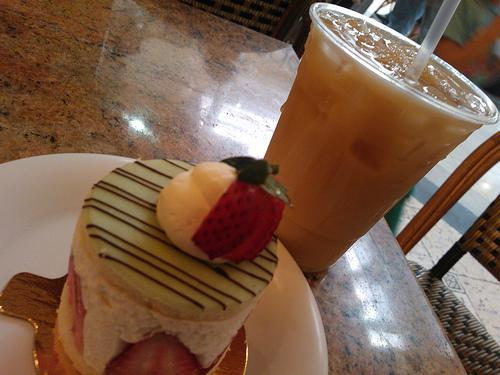Question: what fruit is on top of the dessert?
Choices:
A. Cherries.
B. Strawberry.
C. Raspberries.
D. Blueberries.
Answer with the letter. Answer: B Question: how many desserts are there?
Choices:
A. One.
B. Two.
C. Three.
D. Four.
Answer with the letter. Answer: A Question: what is sticking out of the drink?
Choices:
A. A lemon.
B. A lime.
C. Straw.
D. Ice cubes.
Answer with the letter. Answer: C Question: what is this a picture of?
Choices:
A. A sunset.
B. Food.
C. The sky at night.
D. People.
Answer with the letter. Answer: B 